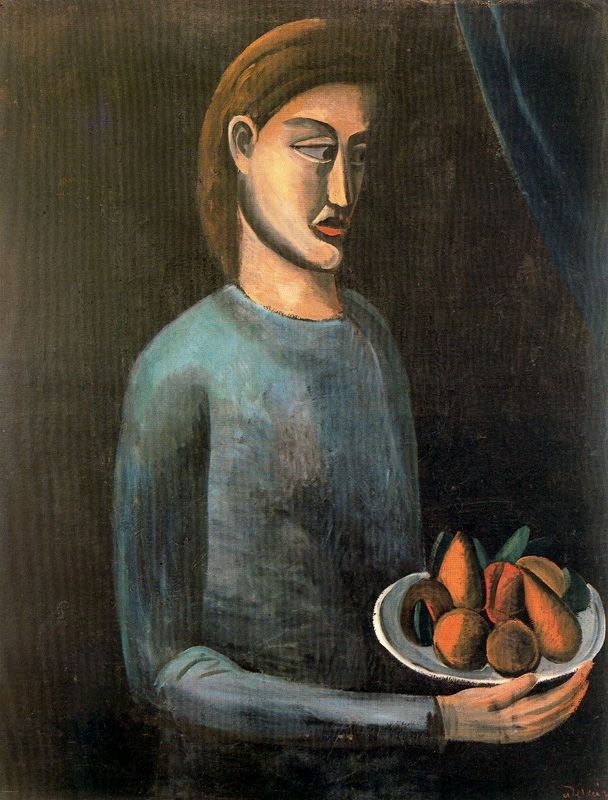Can you discuss how the physical posture and expression of the woman might be significant? The woman's posture, holding the bowl steadfastly but with a gentle grip, coupled with her serene yet somber facial expression, could indicate a quiet strength or resilience. Her expression, particularly the closed eyes and elongated features, often seen in modernist art, may suggest introspection or resignation. This posture and expression align with the modernist themes of exploring the human condition and the complexities of emotional experiences. 